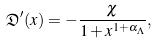<formula> <loc_0><loc_0><loc_500><loc_500>\mathfrak { D } ^ { \prime } ( x ) = - \frac { \chi } { 1 + x ^ { 1 + { \alpha _ { \Lambda } } } } ,</formula> 